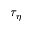Convert formula to latex. <formula><loc_0><loc_0><loc_500><loc_500>\tau _ { \eta }</formula> 